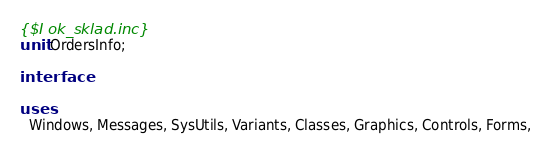Convert code to text. <code><loc_0><loc_0><loc_500><loc_500><_Pascal_>{$I ok_sklad.inc}
unit OrdersInfo;

interface

uses
  Windows, Messages, SysUtils, Variants, Classes, Graphics, Controls, Forms,</code> 